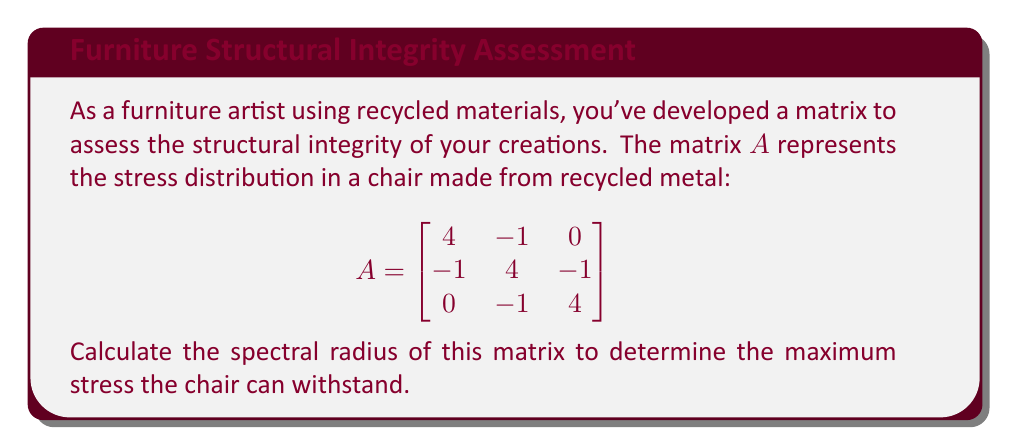Provide a solution to this math problem. To calculate the spectral radius of matrix $A$, we need to follow these steps:

1) First, we need to find the eigenvalues of $A$. The characteristic equation is:

   $\det(A - \lambda I) = 0$

2) Expanding this:

   $$\begin{vmatrix}
   4-\lambda & -1 & 0 \\
   -1 & 4-\lambda & -1 \\
   0 & -1 & 4-\lambda
   \end{vmatrix} = 0$$

3) This gives us the equation:

   $(4-\lambda)[(4-\lambda)(4-\lambda) - 1] - (-1)[-1(4-\lambda)] = 0$

4) Simplifying:

   $(4-\lambda)[(4-\lambda)^2 - 1] + (4-\lambda) = 0$
   $(4-\lambda)[(4-\lambda)^2 - 1 + 1] = 0$
   $(4-\lambda)(4-\lambda)^2 = 0$

5) Solving this equation:

   $\lambda = 4$ (with algebraic multiplicity 3)

6) The spectral radius is the maximum absolute value of the eigenvalues. Since we only have one eigenvalue:

   $\rho(A) = |4| = 4$

Therefore, the spectral radius of the matrix is 4.
Answer: $4$ 